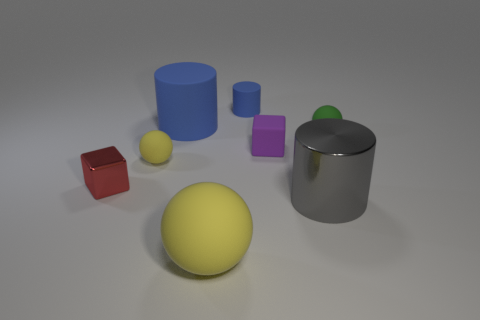Subtract all blue cubes. How many yellow spheres are left? 2 Subtract all blue rubber cylinders. How many cylinders are left? 1 Add 1 large blue cylinders. How many objects exist? 9 Subtract all green spheres. How many spheres are left? 2 Subtract all green cylinders. Subtract all red balls. How many cylinders are left? 3 Subtract all red metallic things. Subtract all tiny red metallic things. How many objects are left? 6 Add 4 large yellow spheres. How many large yellow spheres are left? 5 Add 2 big purple things. How many big purple things exist? 2 Subtract 0 brown balls. How many objects are left? 8 Subtract all cubes. How many objects are left? 6 